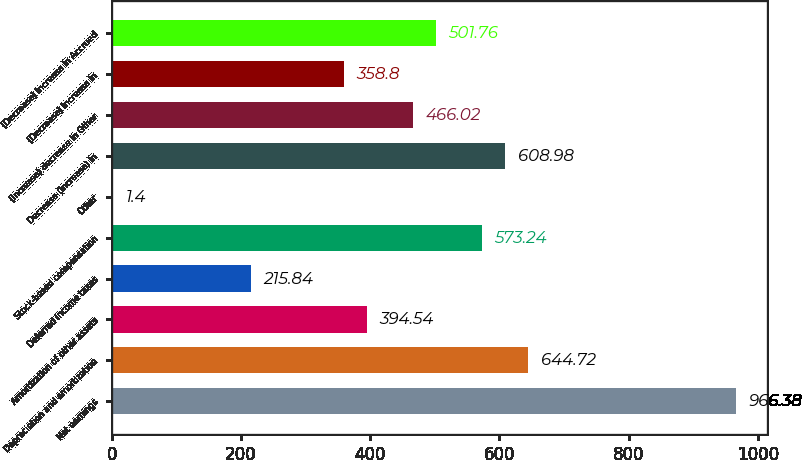Convert chart. <chart><loc_0><loc_0><loc_500><loc_500><bar_chart><fcel>Net earnings<fcel>Depreciation and amortization<fcel>Amortization of other assets<fcel>Deferred income taxes<fcel>Stock-based compensation<fcel>Other<fcel>Decrease (increase) in<fcel>(Increase) decrease in Other<fcel>(Decrease) increase in<fcel>(Decrease) increase in Accrued<nl><fcel>966.38<fcel>644.72<fcel>394.54<fcel>215.84<fcel>573.24<fcel>1.4<fcel>608.98<fcel>466.02<fcel>358.8<fcel>501.76<nl></chart> 